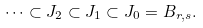<formula> <loc_0><loc_0><loc_500><loc_500>\cdots \subset J _ { 2 } \subset J _ { 1 } \subset J _ { 0 } = B _ { r , s } .</formula> 